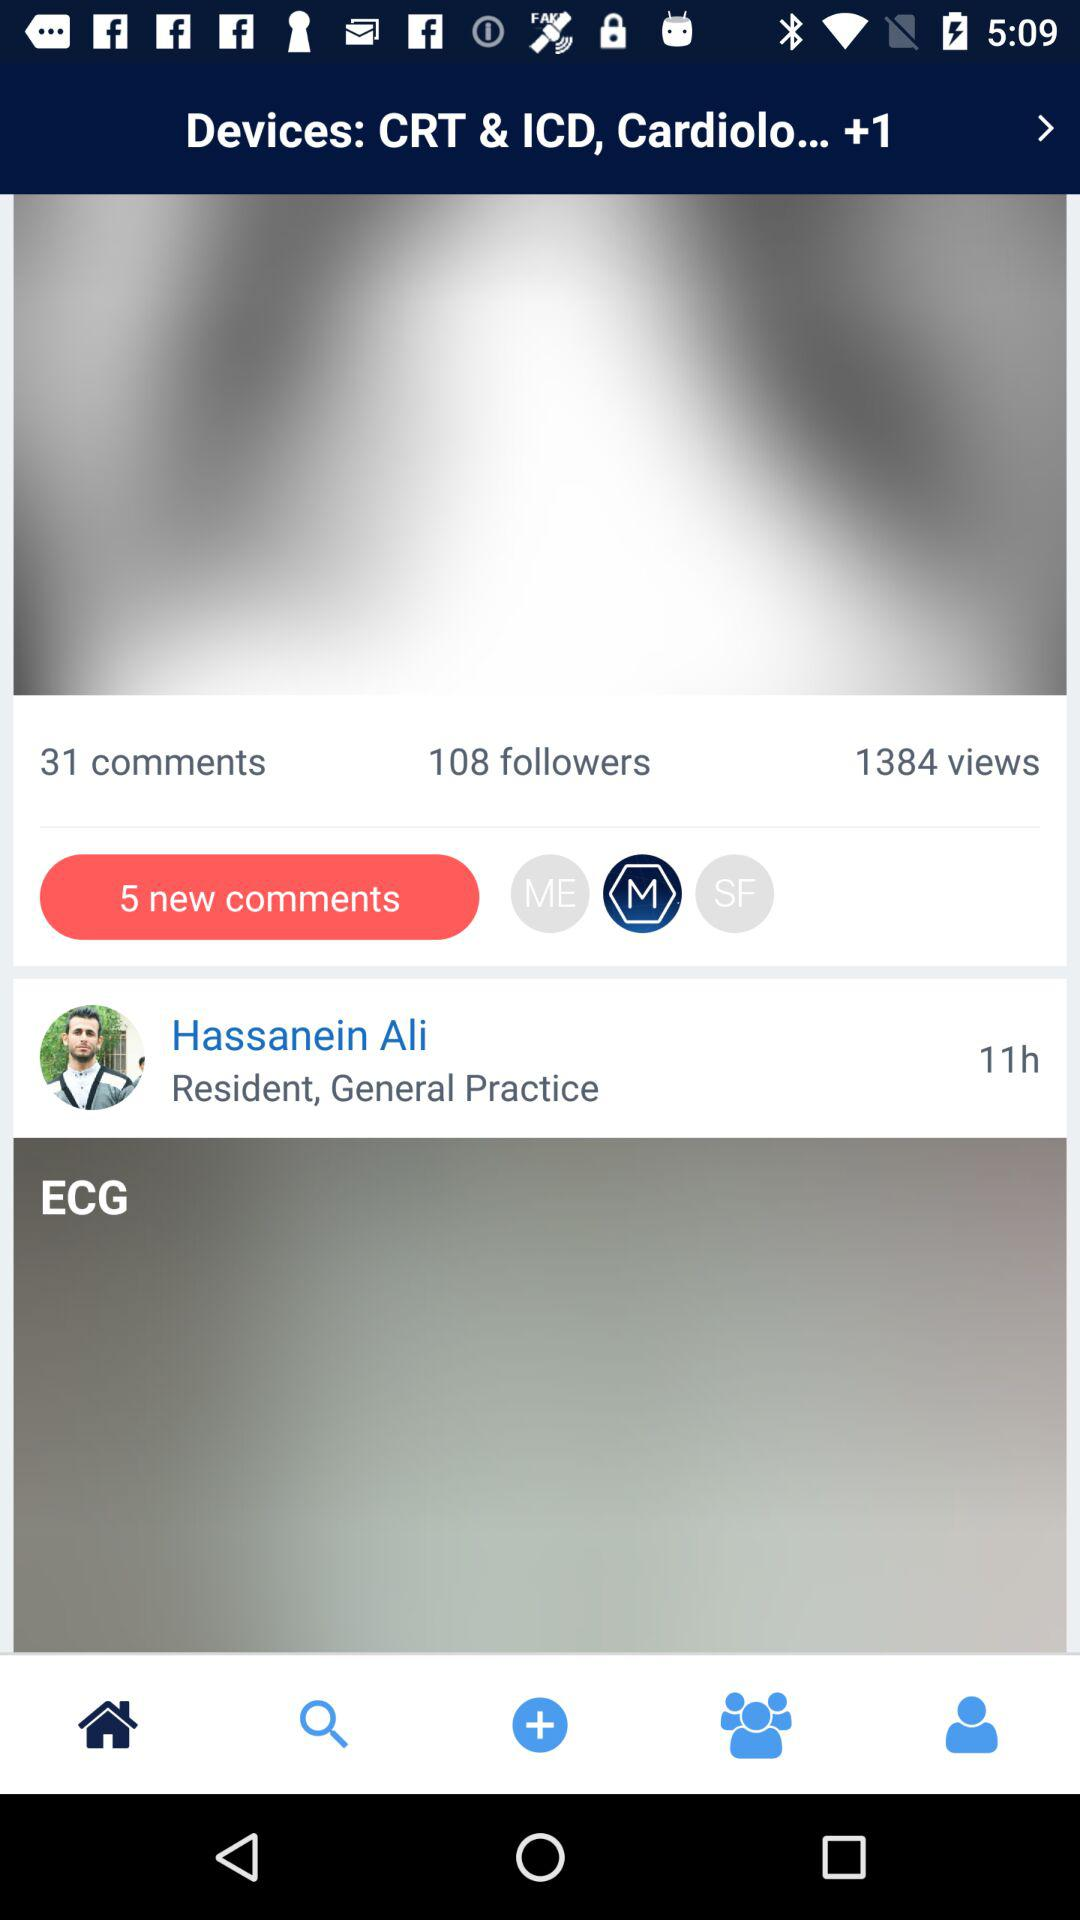How many hours ago did Hassanein Ali post? Hassanein Ali posted 11 hours ago. 